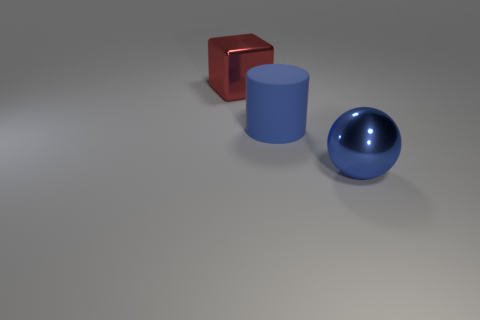Is the material of the blue object that is behind the blue ball the same as the blue thing that is in front of the large rubber cylinder?
Your answer should be compact. No. Are there any tiny brown objects?
Ensure brevity in your answer.  No. Are there more large metallic things that are to the right of the large cube than big red objects that are in front of the rubber cylinder?
Offer a very short reply. Yes. Is the color of the large object on the right side of the blue rubber object the same as the large matte thing behind the large blue shiny ball?
Offer a terse response. Yes. The rubber thing is what shape?
Your response must be concise. Cylinder. Are there more big rubber cylinders that are right of the red block than tiny blue rubber cubes?
Offer a very short reply. Yes. There is a big shiny object on the right side of the red metal block; what shape is it?
Provide a short and direct response. Sphere. How many other things are there of the same shape as the big blue matte thing?
Your answer should be very brief. 0. Does the object that is in front of the blue cylinder have the same material as the large cylinder?
Your answer should be very brief. No. Is the number of shiny blocks on the left side of the red block the same as the number of big matte things that are on the right side of the big blue cylinder?
Provide a short and direct response. Yes. 